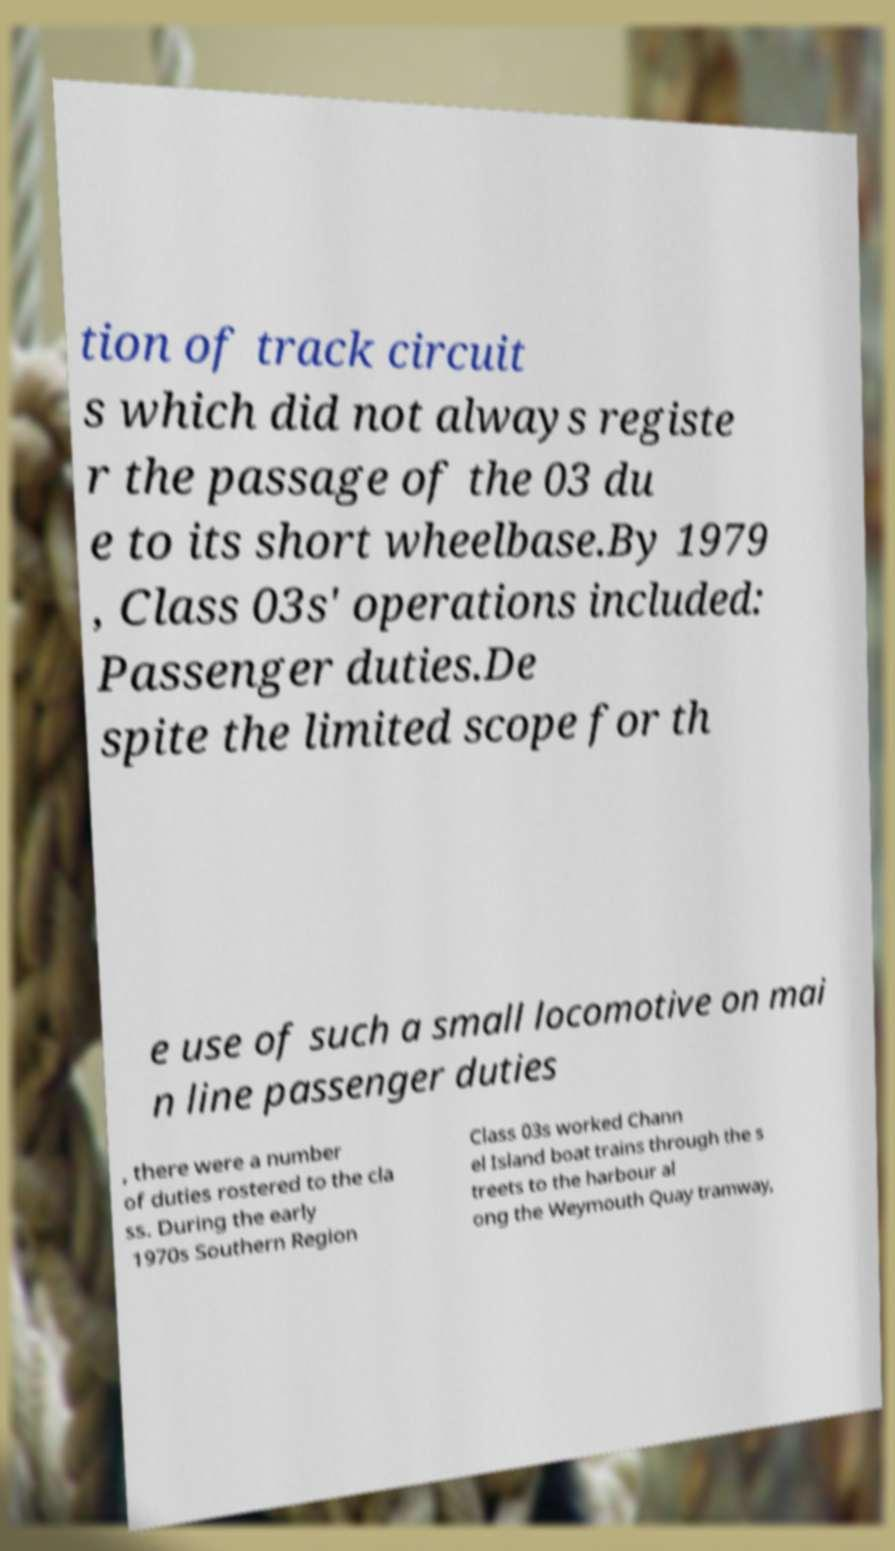Could you extract and type out the text from this image? tion of track circuit s which did not always registe r the passage of the 03 du e to its short wheelbase.By 1979 , Class 03s' operations included: Passenger duties.De spite the limited scope for th e use of such a small locomotive on mai n line passenger duties , there were a number of duties rostered to the cla ss. During the early 1970s Southern Region Class 03s worked Chann el Island boat trains through the s treets to the harbour al ong the Weymouth Quay tramway, 